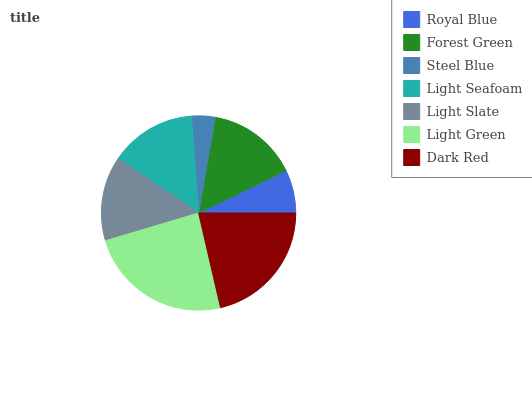Is Steel Blue the minimum?
Answer yes or no. Yes. Is Light Green the maximum?
Answer yes or no. Yes. Is Forest Green the minimum?
Answer yes or no. No. Is Forest Green the maximum?
Answer yes or no. No. Is Forest Green greater than Royal Blue?
Answer yes or no. Yes. Is Royal Blue less than Forest Green?
Answer yes or no. Yes. Is Royal Blue greater than Forest Green?
Answer yes or no. No. Is Forest Green less than Royal Blue?
Answer yes or no. No. Is Light Seafoam the high median?
Answer yes or no. Yes. Is Light Seafoam the low median?
Answer yes or no. Yes. Is Royal Blue the high median?
Answer yes or no. No. Is Steel Blue the low median?
Answer yes or no. No. 